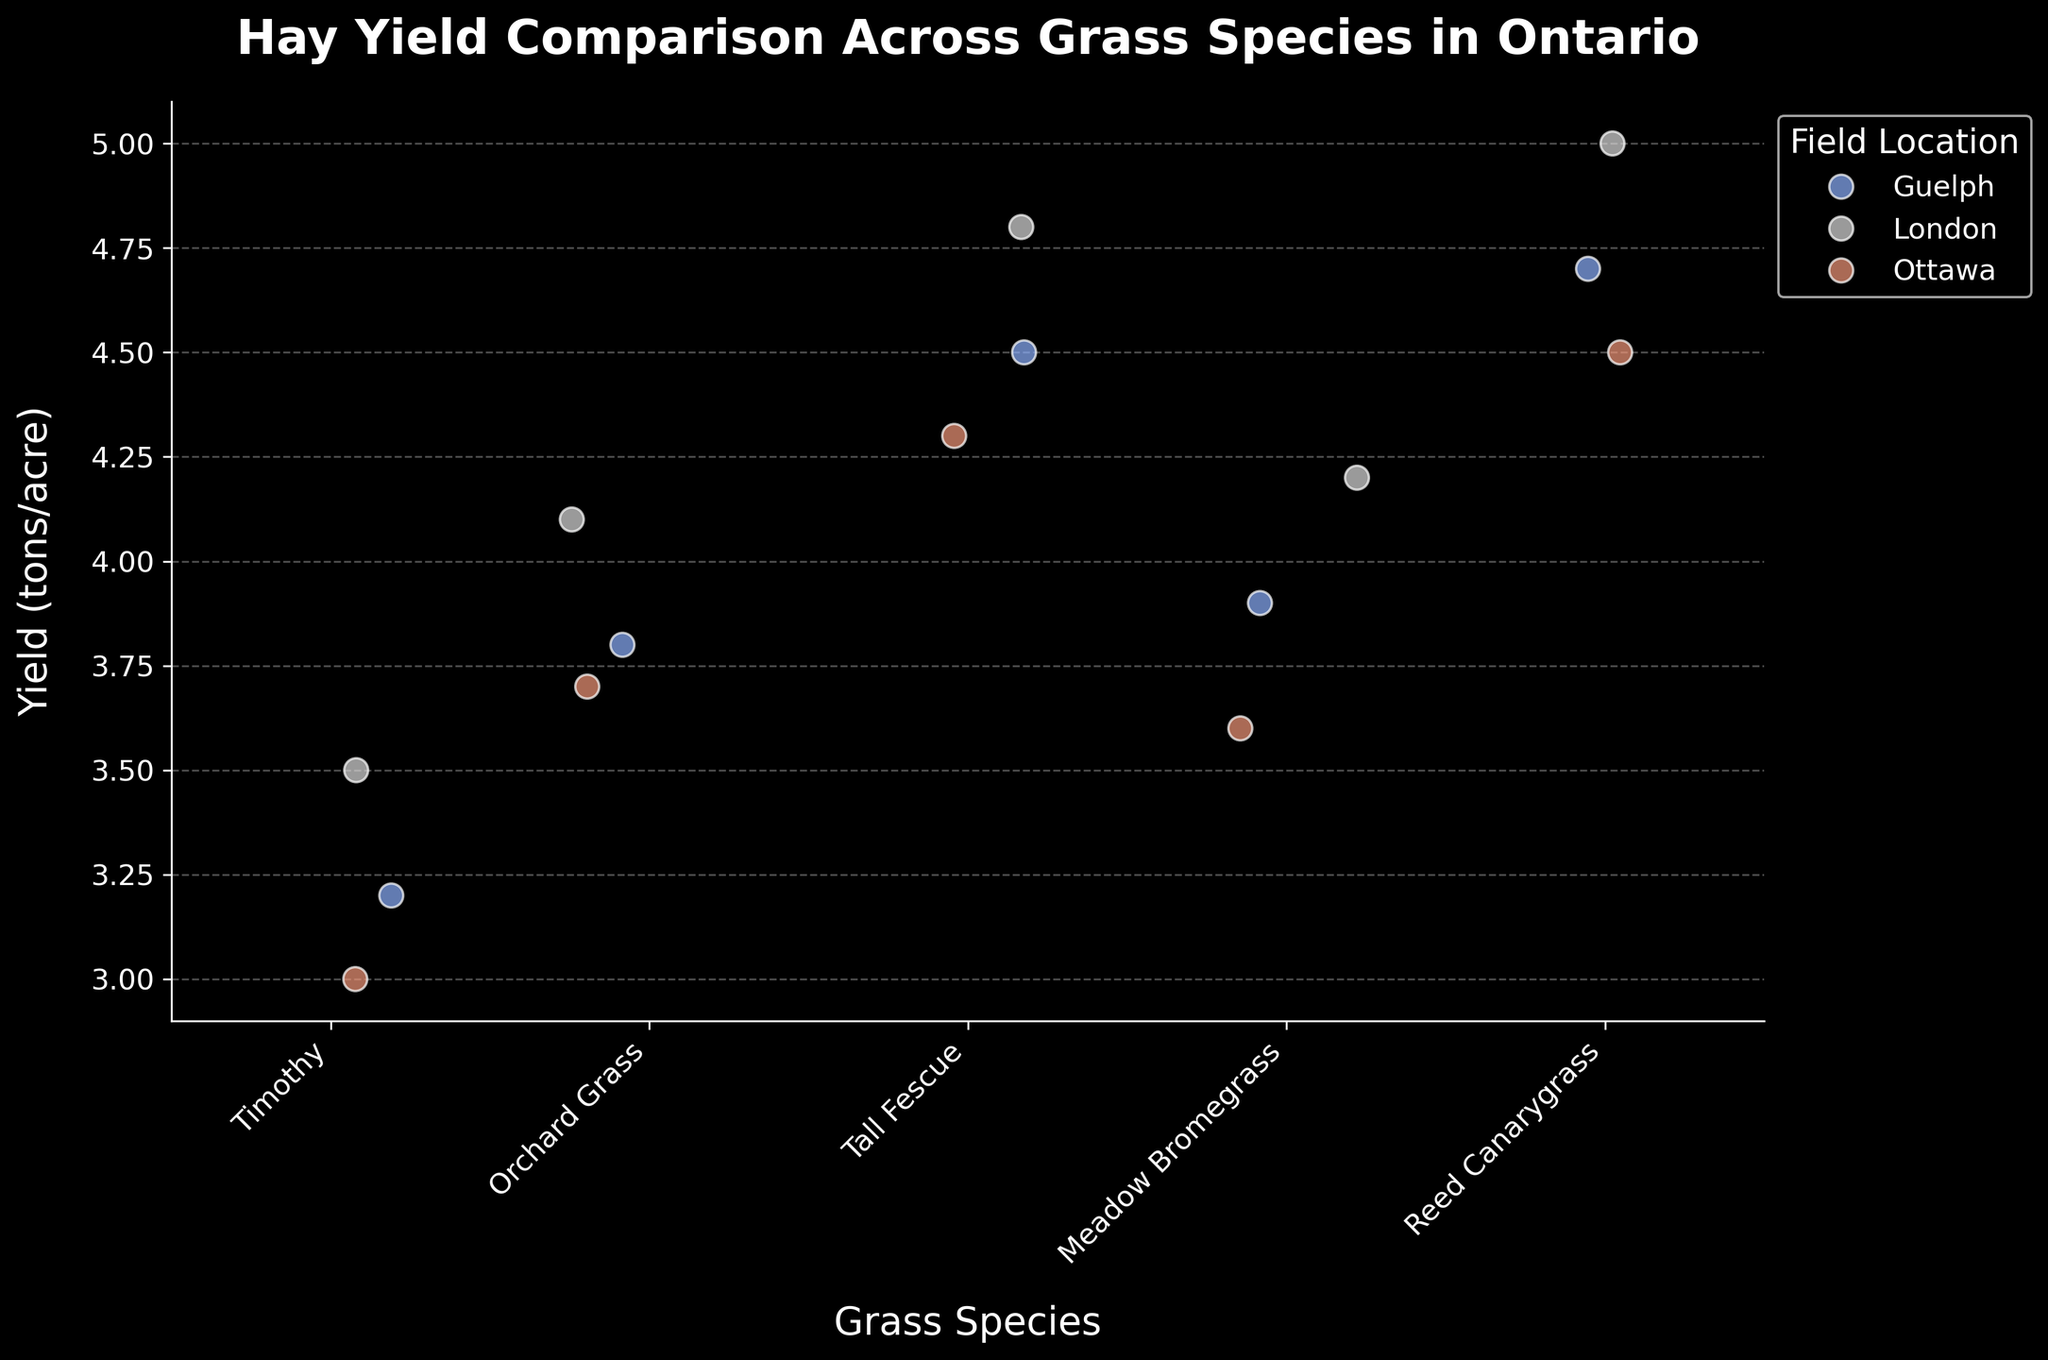How many different field locations are represented in the plot? The plot uses a color legend for field locations. By counting the distinct colors, we can identify three field locations: Guelph, London, and Ottawa.
Answer: 3 What is the title of the plot? The title is usually located at the top of the figure and reads, "Hay Yield Comparison Across Grass Species in Ontario."
Answer: Hay Yield Comparison Across Grass Species in Ontario Which grass species has the highest maximum yield and what is its value? By examining the highest data points, Reed Canarygrass shows the highest maximum yield at London, which is 5.0 tons/acre.
Answer: Reed Canarygrass, 5.0 tons/acre Among the data points for Timothy at different locations, which field has the lowest yield? Timothy shows data points for Guelph, London, and Ottawa. The lowest yield for Timothy is 3.0 tons/acre in Ottawa.
Answer: Ottawa What's the difference in yield between the highest and lowest points for Tall Fescue? The yields for Tall Fescue are 4.5 tons/acre (Guelph), 4.8 tons/acre (London), and 4.3 tons/acre (Ottawa). The difference between the highest (4.8) and lowest (4.3) yields is 0.5 tons/acre.
Answer: 0.5 tons/acre Which field location has the most consistent yields across all grass species? By looking at how close the points are for each field location across species, Guelph shows the most consistent yields, as the points across different species are closer together.
Answer: Guelph Compare the average yields of Orchard Grass and Meadow Bromegrass. Which one is higher? Orchard Grass has yields of 3.8, 4.1, and 3.7 tons/acre. Meadow Bromegrass has yields of 3.9, 4.2, and 3.6 tons/acre. Calculating the averages, Orchard Grass’s average is (3.8+4.1+3.7)/3 = 3.87, and Meadow Bromegrass’s average is (3.9+4.2+3.6)/3 = 3.9. Therefore, Meadow Bromegrass has a higher average yield.
Answer: Meadow Bromegrass How do the yields of Tall Fescue compare to other grass species at the London field location? At the London location, Tall Fescue has a yield of 4.8 tons/acre. This is higher than the yields of Timothy (3.5), Orchard Grass (4.1), Meadow Bromegrass (4.2), but lower than Reed Canarygrass (5.0).
Answer: Higher than Timothy, Orchard Grass, Meadow Bromegrass; lower than Reed Canarygrass Which grass species shows the most variation in yields across different field locations? Reed Canarygrass exhibits yields of 4.7, 5.0, and 4.5 tons/acre. The range is largest here compared to other species. Calculate the range by subtracting the lowest value from the highest, giving a range of 5.0 - 4.5 = 0.5 for Reed Canarygrass. Other species were checked and have smaller ranges.
Answer: Reed Canarygrass 